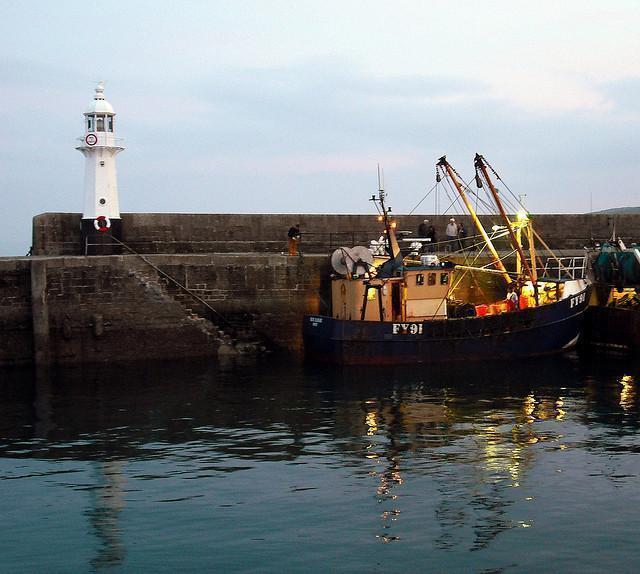When it is dark at night what will the boats use as navigation?
Answer the question by selecting the correct answer among the 4 following choices.
Options: Moonlight, flashlights, radar, lighthouse. Lighthouse. 